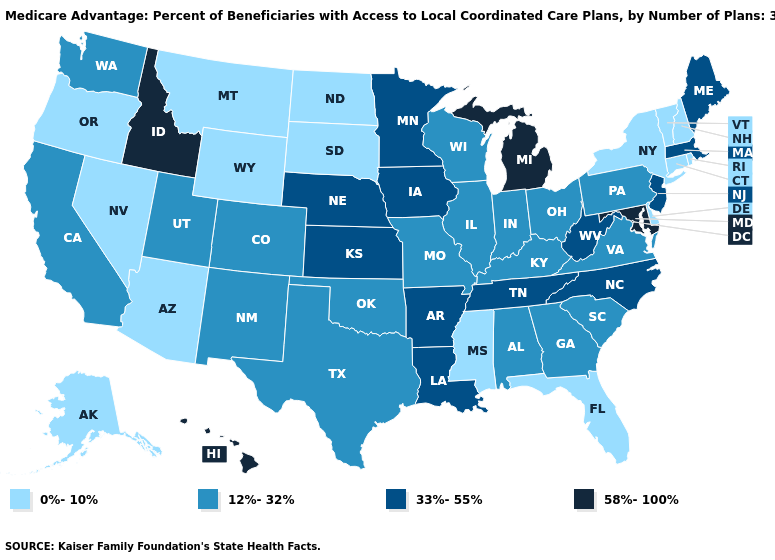What is the highest value in the South ?
Short answer required. 58%-100%. What is the value of Kansas?
Short answer required. 33%-55%. What is the value of Michigan?
Short answer required. 58%-100%. Does the map have missing data?
Concise answer only. No. Among the states that border New York , does New Jersey have the lowest value?
Quick response, please. No. What is the value of Delaware?
Concise answer only. 0%-10%. Which states have the lowest value in the USA?
Write a very short answer. Alaska, Arizona, Connecticut, Delaware, Florida, Mississippi, Montana, North Dakota, New Hampshire, Nevada, New York, Oregon, Rhode Island, South Dakota, Vermont, Wyoming. Name the states that have a value in the range 12%-32%?
Be succinct. Alabama, California, Colorado, Georgia, Illinois, Indiana, Kentucky, Missouri, New Mexico, Ohio, Oklahoma, Pennsylvania, South Carolina, Texas, Utah, Virginia, Washington, Wisconsin. What is the highest value in the MidWest ?
Keep it brief. 58%-100%. Among the states that border Indiana , does Michigan have the highest value?
Keep it brief. Yes. Name the states that have a value in the range 33%-55%?
Quick response, please. Arkansas, Iowa, Kansas, Louisiana, Massachusetts, Maine, Minnesota, North Carolina, Nebraska, New Jersey, Tennessee, West Virginia. Which states have the lowest value in the MidWest?
Short answer required. North Dakota, South Dakota. Which states have the lowest value in the South?
Short answer required. Delaware, Florida, Mississippi. Does Idaho have the highest value in the West?
Answer briefly. Yes. Name the states that have a value in the range 0%-10%?
Give a very brief answer. Alaska, Arizona, Connecticut, Delaware, Florida, Mississippi, Montana, North Dakota, New Hampshire, Nevada, New York, Oregon, Rhode Island, South Dakota, Vermont, Wyoming. 